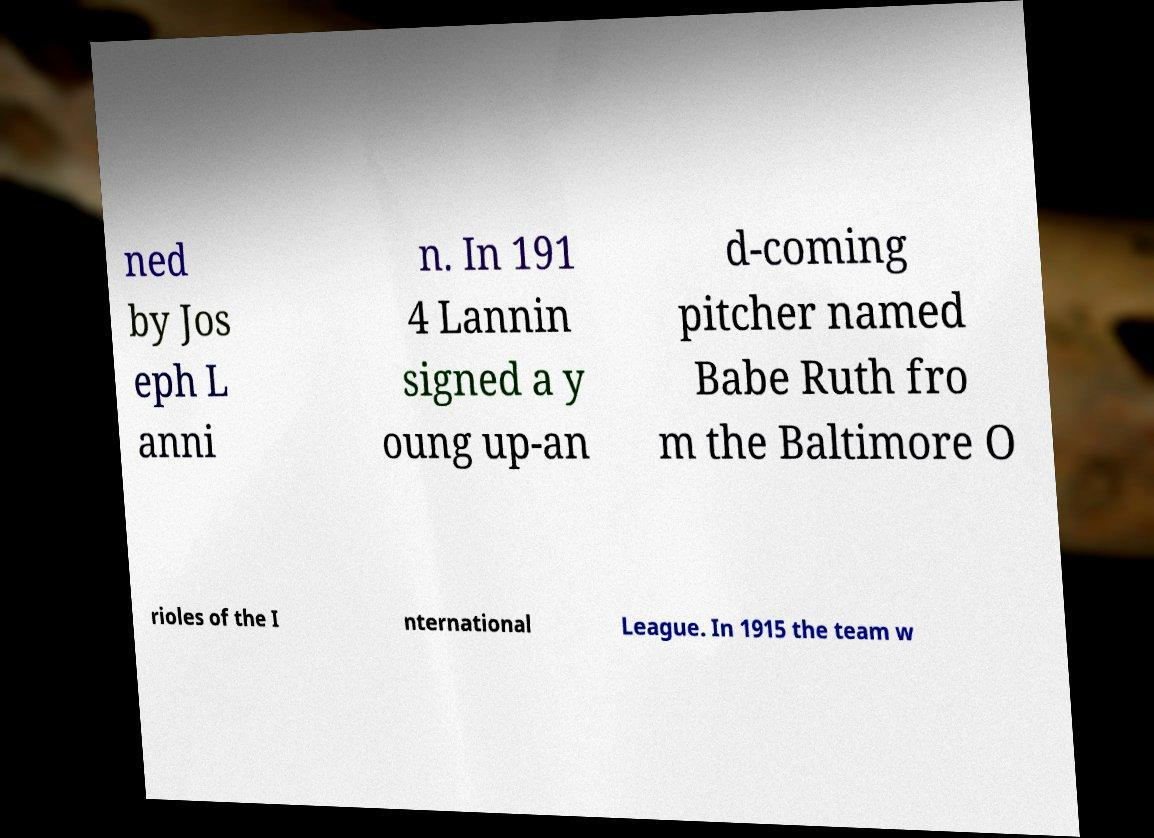What messages or text are displayed in this image? I need them in a readable, typed format. ned by Jos eph L anni n. In 191 4 Lannin signed a y oung up-an d-coming pitcher named Babe Ruth fro m the Baltimore O rioles of the I nternational League. In 1915 the team w 